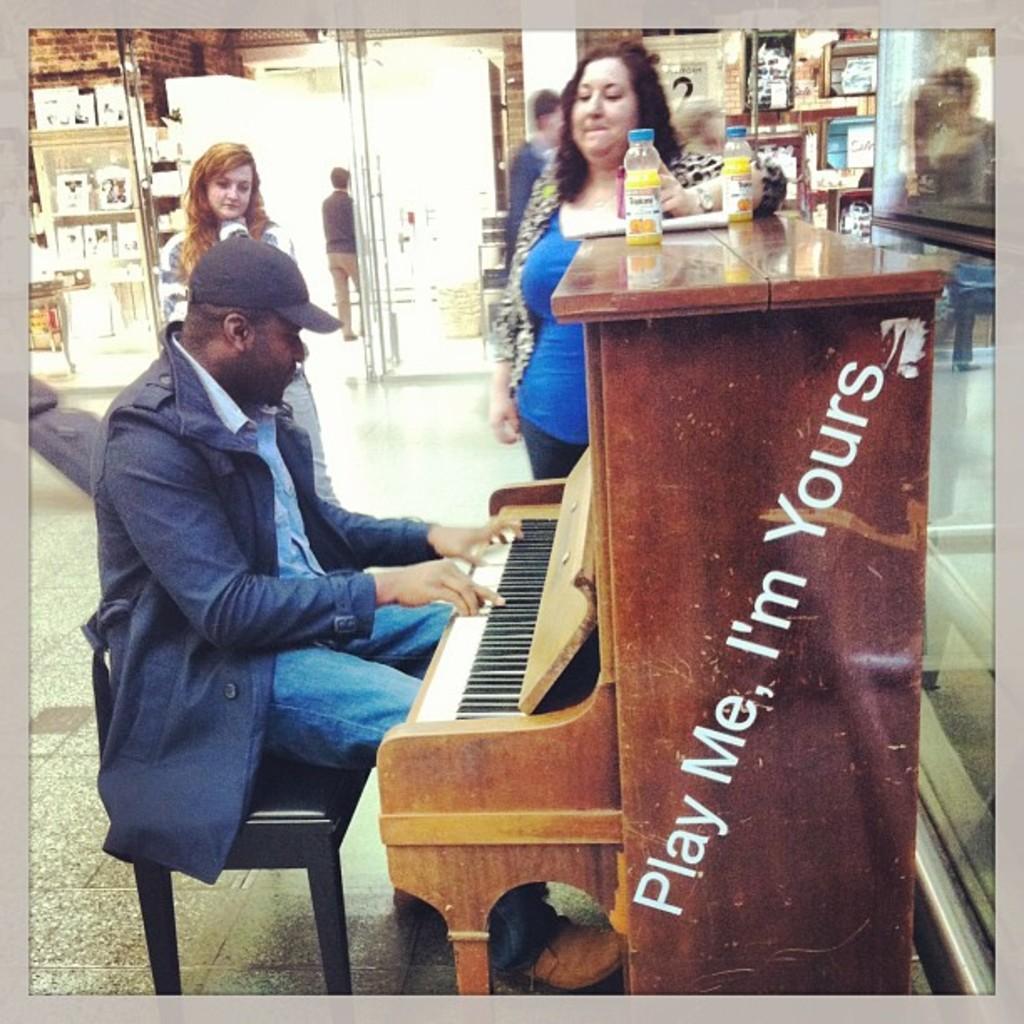In one or two sentences, can you explain what this image depicts? There is a person sitting on a wooden chair and he is playing a piano. There is a woman standing in the center and she is having a look at this person. 